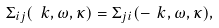Convert formula to latex. <formula><loc_0><loc_0><loc_500><loc_500>\Sigma _ { i j } ( \ k , \omega , \kappa ) = \Sigma _ { j i } ( - \ k , \omega , \kappa ) ,</formula> 